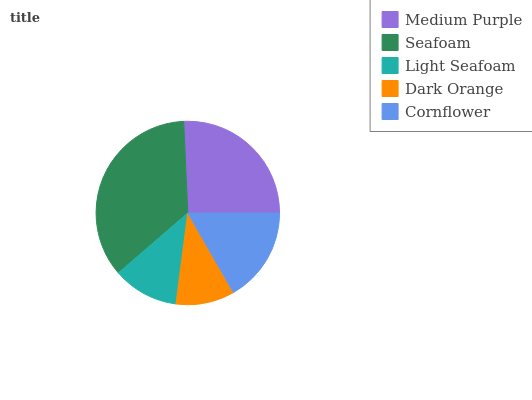Is Dark Orange the minimum?
Answer yes or no. Yes. Is Seafoam the maximum?
Answer yes or no. Yes. Is Light Seafoam the minimum?
Answer yes or no. No. Is Light Seafoam the maximum?
Answer yes or no. No. Is Seafoam greater than Light Seafoam?
Answer yes or no. Yes. Is Light Seafoam less than Seafoam?
Answer yes or no. Yes. Is Light Seafoam greater than Seafoam?
Answer yes or no. No. Is Seafoam less than Light Seafoam?
Answer yes or no. No. Is Cornflower the high median?
Answer yes or no. Yes. Is Cornflower the low median?
Answer yes or no. Yes. Is Seafoam the high median?
Answer yes or no. No. Is Dark Orange the low median?
Answer yes or no. No. 